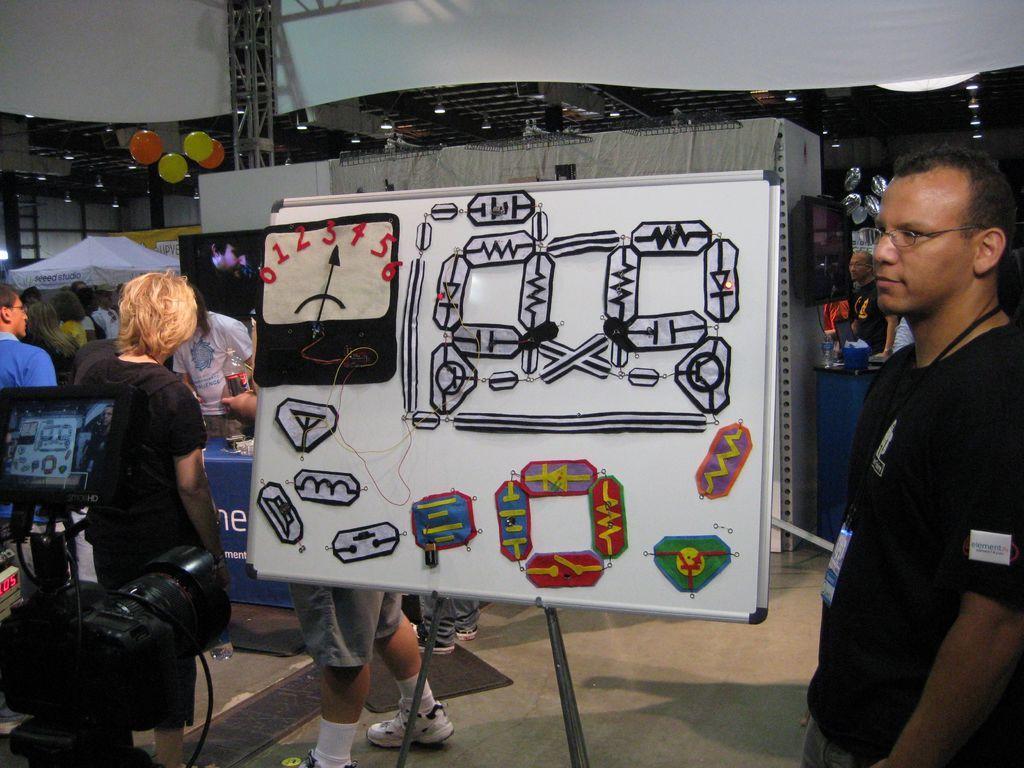Can you describe this image briefly? In this image I can see few people. I can see the camera, tent, screen, lights, poles, balloons and few objects on the tables. In front I can see few objects are attached to the white color board. 